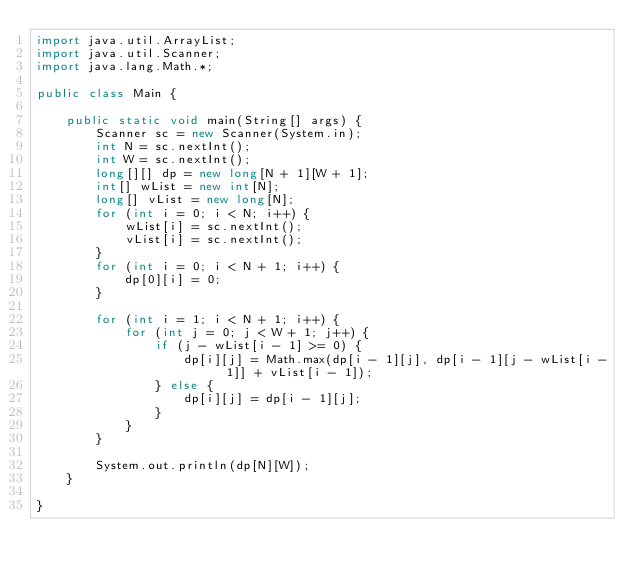Convert code to text. <code><loc_0><loc_0><loc_500><loc_500><_Java_>import java.util.ArrayList;
import java.util.Scanner;
import java.lang.Math.*;

public class Main {

	public static void main(String[] args) {
		Scanner sc = new Scanner(System.in);
		int N = sc.nextInt();
		int W = sc.nextInt();
		long[][] dp = new long[N + 1][W + 1];
		int[] wList = new int[N];
		long[] vList = new long[N];
		for (int i = 0; i < N; i++) {
			wList[i] = sc.nextInt();
			vList[i] = sc.nextInt();
		}
		for (int i = 0; i < N + 1; i++) {
			dp[0][i] = 0;
		}

		for (int i = 1; i < N + 1; i++) {
			for (int j = 0; j < W + 1; j++) {
				if (j - wList[i - 1] >= 0) {
					dp[i][j] = Math.max(dp[i - 1][j], dp[i - 1][j - wList[i - 1]] + vList[i - 1]);
				} else {
					dp[i][j] = dp[i - 1][j];
				}
			}
		}

		System.out.println(dp[N][W]);
	}

}
</code> 